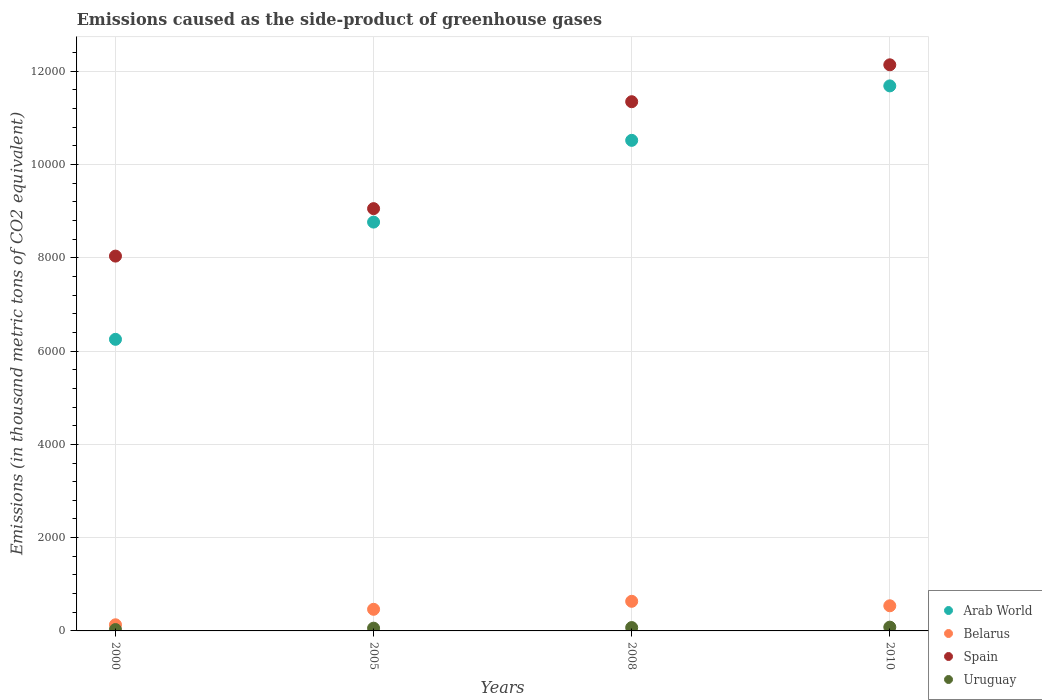What is the emissions caused as the side-product of greenhouse gases in Spain in 2000?
Provide a succinct answer. 8037.1. Across all years, what is the maximum emissions caused as the side-product of greenhouse gases in Belarus?
Give a very brief answer. 635.2. Across all years, what is the minimum emissions caused as the side-product of greenhouse gases in Belarus?
Your response must be concise. 131.6. In which year was the emissions caused as the side-product of greenhouse gases in Arab World maximum?
Make the answer very short. 2010. What is the total emissions caused as the side-product of greenhouse gases in Belarus in the graph?
Offer a terse response. 1769.4. What is the difference between the emissions caused as the side-product of greenhouse gases in Spain in 2000 and that in 2005?
Offer a very short reply. -1018. What is the difference between the emissions caused as the side-product of greenhouse gases in Belarus in 2008 and the emissions caused as the side-product of greenhouse gases in Arab World in 2010?
Your answer should be compact. -1.11e+04. What is the average emissions caused as the side-product of greenhouse gases in Spain per year?
Make the answer very short. 1.01e+04. In the year 2010, what is the difference between the emissions caused as the side-product of greenhouse gases in Arab World and emissions caused as the side-product of greenhouse gases in Spain?
Keep it short and to the point. -452. What is the ratio of the emissions caused as the side-product of greenhouse gases in Spain in 2005 to that in 2008?
Offer a very short reply. 0.8. Is the emissions caused as the side-product of greenhouse gases in Uruguay in 2000 less than that in 2010?
Your answer should be compact. Yes. Is the difference between the emissions caused as the side-product of greenhouse gases in Arab World in 2000 and 2010 greater than the difference between the emissions caused as the side-product of greenhouse gases in Spain in 2000 and 2010?
Give a very brief answer. No. What is the difference between the highest and the second highest emissions caused as the side-product of greenhouse gases in Belarus?
Keep it short and to the point. 96.2. What is the difference between the highest and the lowest emissions caused as the side-product of greenhouse gases in Spain?
Provide a short and direct response. 4101.9. Is it the case that in every year, the sum of the emissions caused as the side-product of greenhouse gases in Belarus and emissions caused as the side-product of greenhouse gases in Arab World  is greater than the sum of emissions caused as the side-product of greenhouse gases in Uruguay and emissions caused as the side-product of greenhouse gases in Spain?
Offer a terse response. No. Is the emissions caused as the side-product of greenhouse gases in Uruguay strictly less than the emissions caused as the side-product of greenhouse gases in Belarus over the years?
Offer a terse response. Yes. How many dotlines are there?
Your answer should be very brief. 4. How many years are there in the graph?
Your answer should be very brief. 4. What is the difference between two consecutive major ticks on the Y-axis?
Give a very brief answer. 2000. Are the values on the major ticks of Y-axis written in scientific E-notation?
Give a very brief answer. No. Does the graph contain any zero values?
Provide a succinct answer. No. Does the graph contain grids?
Keep it short and to the point. Yes. Where does the legend appear in the graph?
Keep it short and to the point. Bottom right. How many legend labels are there?
Offer a terse response. 4. What is the title of the graph?
Make the answer very short. Emissions caused as the side-product of greenhouse gases. Does "Middle East & North Africa (developing only)" appear as one of the legend labels in the graph?
Ensure brevity in your answer.  No. What is the label or title of the X-axis?
Offer a terse response. Years. What is the label or title of the Y-axis?
Keep it short and to the point. Emissions (in thousand metric tons of CO2 equivalent). What is the Emissions (in thousand metric tons of CO2 equivalent) in Arab World in 2000?
Ensure brevity in your answer.  6252.6. What is the Emissions (in thousand metric tons of CO2 equivalent) of Belarus in 2000?
Provide a succinct answer. 131.6. What is the Emissions (in thousand metric tons of CO2 equivalent) of Spain in 2000?
Ensure brevity in your answer.  8037.1. What is the Emissions (in thousand metric tons of CO2 equivalent) of Uruguay in 2000?
Offer a terse response. 29.3. What is the Emissions (in thousand metric tons of CO2 equivalent) in Arab World in 2005?
Give a very brief answer. 8766.4. What is the Emissions (in thousand metric tons of CO2 equivalent) in Belarus in 2005?
Ensure brevity in your answer.  463.6. What is the Emissions (in thousand metric tons of CO2 equivalent) of Spain in 2005?
Provide a short and direct response. 9055.1. What is the Emissions (in thousand metric tons of CO2 equivalent) of Uruguay in 2005?
Provide a succinct answer. 58.7. What is the Emissions (in thousand metric tons of CO2 equivalent) of Arab World in 2008?
Keep it short and to the point. 1.05e+04. What is the Emissions (in thousand metric tons of CO2 equivalent) in Belarus in 2008?
Your answer should be compact. 635.2. What is the Emissions (in thousand metric tons of CO2 equivalent) of Spain in 2008?
Provide a short and direct response. 1.13e+04. What is the Emissions (in thousand metric tons of CO2 equivalent) of Uruguay in 2008?
Provide a succinct answer. 71.8. What is the Emissions (in thousand metric tons of CO2 equivalent) of Arab World in 2010?
Offer a terse response. 1.17e+04. What is the Emissions (in thousand metric tons of CO2 equivalent) of Belarus in 2010?
Make the answer very short. 539. What is the Emissions (in thousand metric tons of CO2 equivalent) in Spain in 2010?
Ensure brevity in your answer.  1.21e+04. What is the Emissions (in thousand metric tons of CO2 equivalent) of Uruguay in 2010?
Ensure brevity in your answer.  81. Across all years, what is the maximum Emissions (in thousand metric tons of CO2 equivalent) in Arab World?
Your answer should be very brief. 1.17e+04. Across all years, what is the maximum Emissions (in thousand metric tons of CO2 equivalent) in Belarus?
Provide a short and direct response. 635.2. Across all years, what is the maximum Emissions (in thousand metric tons of CO2 equivalent) in Spain?
Offer a terse response. 1.21e+04. Across all years, what is the minimum Emissions (in thousand metric tons of CO2 equivalent) of Arab World?
Make the answer very short. 6252.6. Across all years, what is the minimum Emissions (in thousand metric tons of CO2 equivalent) of Belarus?
Your answer should be compact. 131.6. Across all years, what is the minimum Emissions (in thousand metric tons of CO2 equivalent) of Spain?
Offer a very short reply. 8037.1. Across all years, what is the minimum Emissions (in thousand metric tons of CO2 equivalent) of Uruguay?
Your answer should be very brief. 29.3. What is the total Emissions (in thousand metric tons of CO2 equivalent) of Arab World in the graph?
Give a very brief answer. 3.72e+04. What is the total Emissions (in thousand metric tons of CO2 equivalent) in Belarus in the graph?
Offer a very short reply. 1769.4. What is the total Emissions (in thousand metric tons of CO2 equivalent) in Spain in the graph?
Keep it short and to the point. 4.06e+04. What is the total Emissions (in thousand metric tons of CO2 equivalent) of Uruguay in the graph?
Your answer should be very brief. 240.8. What is the difference between the Emissions (in thousand metric tons of CO2 equivalent) in Arab World in 2000 and that in 2005?
Keep it short and to the point. -2513.8. What is the difference between the Emissions (in thousand metric tons of CO2 equivalent) of Belarus in 2000 and that in 2005?
Provide a short and direct response. -332. What is the difference between the Emissions (in thousand metric tons of CO2 equivalent) in Spain in 2000 and that in 2005?
Offer a very short reply. -1018. What is the difference between the Emissions (in thousand metric tons of CO2 equivalent) of Uruguay in 2000 and that in 2005?
Keep it short and to the point. -29.4. What is the difference between the Emissions (in thousand metric tons of CO2 equivalent) of Arab World in 2000 and that in 2008?
Keep it short and to the point. -4266.6. What is the difference between the Emissions (in thousand metric tons of CO2 equivalent) in Belarus in 2000 and that in 2008?
Provide a succinct answer. -503.6. What is the difference between the Emissions (in thousand metric tons of CO2 equivalent) of Spain in 2000 and that in 2008?
Give a very brief answer. -3310.7. What is the difference between the Emissions (in thousand metric tons of CO2 equivalent) of Uruguay in 2000 and that in 2008?
Your answer should be very brief. -42.5. What is the difference between the Emissions (in thousand metric tons of CO2 equivalent) in Arab World in 2000 and that in 2010?
Provide a short and direct response. -5434.4. What is the difference between the Emissions (in thousand metric tons of CO2 equivalent) of Belarus in 2000 and that in 2010?
Your response must be concise. -407.4. What is the difference between the Emissions (in thousand metric tons of CO2 equivalent) in Spain in 2000 and that in 2010?
Provide a succinct answer. -4101.9. What is the difference between the Emissions (in thousand metric tons of CO2 equivalent) in Uruguay in 2000 and that in 2010?
Your answer should be very brief. -51.7. What is the difference between the Emissions (in thousand metric tons of CO2 equivalent) in Arab World in 2005 and that in 2008?
Make the answer very short. -1752.8. What is the difference between the Emissions (in thousand metric tons of CO2 equivalent) of Belarus in 2005 and that in 2008?
Ensure brevity in your answer.  -171.6. What is the difference between the Emissions (in thousand metric tons of CO2 equivalent) in Spain in 2005 and that in 2008?
Offer a terse response. -2292.7. What is the difference between the Emissions (in thousand metric tons of CO2 equivalent) of Uruguay in 2005 and that in 2008?
Offer a very short reply. -13.1. What is the difference between the Emissions (in thousand metric tons of CO2 equivalent) of Arab World in 2005 and that in 2010?
Provide a short and direct response. -2920.6. What is the difference between the Emissions (in thousand metric tons of CO2 equivalent) of Belarus in 2005 and that in 2010?
Provide a succinct answer. -75.4. What is the difference between the Emissions (in thousand metric tons of CO2 equivalent) of Spain in 2005 and that in 2010?
Your response must be concise. -3083.9. What is the difference between the Emissions (in thousand metric tons of CO2 equivalent) in Uruguay in 2005 and that in 2010?
Your response must be concise. -22.3. What is the difference between the Emissions (in thousand metric tons of CO2 equivalent) of Arab World in 2008 and that in 2010?
Provide a succinct answer. -1167.8. What is the difference between the Emissions (in thousand metric tons of CO2 equivalent) in Belarus in 2008 and that in 2010?
Your answer should be compact. 96.2. What is the difference between the Emissions (in thousand metric tons of CO2 equivalent) in Spain in 2008 and that in 2010?
Give a very brief answer. -791.2. What is the difference between the Emissions (in thousand metric tons of CO2 equivalent) of Uruguay in 2008 and that in 2010?
Keep it short and to the point. -9.2. What is the difference between the Emissions (in thousand metric tons of CO2 equivalent) of Arab World in 2000 and the Emissions (in thousand metric tons of CO2 equivalent) of Belarus in 2005?
Your answer should be very brief. 5789. What is the difference between the Emissions (in thousand metric tons of CO2 equivalent) of Arab World in 2000 and the Emissions (in thousand metric tons of CO2 equivalent) of Spain in 2005?
Provide a succinct answer. -2802.5. What is the difference between the Emissions (in thousand metric tons of CO2 equivalent) in Arab World in 2000 and the Emissions (in thousand metric tons of CO2 equivalent) in Uruguay in 2005?
Keep it short and to the point. 6193.9. What is the difference between the Emissions (in thousand metric tons of CO2 equivalent) of Belarus in 2000 and the Emissions (in thousand metric tons of CO2 equivalent) of Spain in 2005?
Give a very brief answer. -8923.5. What is the difference between the Emissions (in thousand metric tons of CO2 equivalent) of Belarus in 2000 and the Emissions (in thousand metric tons of CO2 equivalent) of Uruguay in 2005?
Your answer should be very brief. 72.9. What is the difference between the Emissions (in thousand metric tons of CO2 equivalent) in Spain in 2000 and the Emissions (in thousand metric tons of CO2 equivalent) in Uruguay in 2005?
Keep it short and to the point. 7978.4. What is the difference between the Emissions (in thousand metric tons of CO2 equivalent) in Arab World in 2000 and the Emissions (in thousand metric tons of CO2 equivalent) in Belarus in 2008?
Your response must be concise. 5617.4. What is the difference between the Emissions (in thousand metric tons of CO2 equivalent) in Arab World in 2000 and the Emissions (in thousand metric tons of CO2 equivalent) in Spain in 2008?
Make the answer very short. -5095.2. What is the difference between the Emissions (in thousand metric tons of CO2 equivalent) in Arab World in 2000 and the Emissions (in thousand metric tons of CO2 equivalent) in Uruguay in 2008?
Keep it short and to the point. 6180.8. What is the difference between the Emissions (in thousand metric tons of CO2 equivalent) of Belarus in 2000 and the Emissions (in thousand metric tons of CO2 equivalent) of Spain in 2008?
Make the answer very short. -1.12e+04. What is the difference between the Emissions (in thousand metric tons of CO2 equivalent) of Belarus in 2000 and the Emissions (in thousand metric tons of CO2 equivalent) of Uruguay in 2008?
Offer a terse response. 59.8. What is the difference between the Emissions (in thousand metric tons of CO2 equivalent) in Spain in 2000 and the Emissions (in thousand metric tons of CO2 equivalent) in Uruguay in 2008?
Your answer should be compact. 7965.3. What is the difference between the Emissions (in thousand metric tons of CO2 equivalent) of Arab World in 2000 and the Emissions (in thousand metric tons of CO2 equivalent) of Belarus in 2010?
Provide a succinct answer. 5713.6. What is the difference between the Emissions (in thousand metric tons of CO2 equivalent) of Arab World in 2000 and the Emissions (in thousand metric tons of CO2 equivalent) of Spain in 2010?
Keep it short and to the point. -5886.4. What is the difference between the Emissions (in thousand metric tons of CO2 equivalent) of Arab World in 2000 and the Emissions (in thousand metric tons of CO2 equivalent) of Uruguay in 2010?
Your answer should be compact. 6171.6. What is the difference between the Emissions (in thousand metric tons of CO2 equivalent) in Belarus in 2000 and the Emissions (in thousand metric tons of CO2 equivalent) in Spain in 2010?
Keep it short and to the point. -1.20e+04. What is the difference between the Emissions (in thousand metric tons of CO2 equivalent) in Belarus in 2000 and the Emissions (in thousand metric tons of CO2 equivalent) in Uruguay in 2010?
Your response must be concise. 50.6. What is the difference between the Emissions (in thousand metric tons of CO2 equivalent) in Spain in 2000 and the Emissions (in thousand metric tons of CO2 equivalent) in Uruguay in 2010?
Make the answer very short. 7956.1. What is the difference between the Emissions (in thousand metric tons of CO2 equivalent) of Arab World in 2005 and the Emissions (in thousand metric tons of CO2 equivalent) of Belarus in 2008?
Your response must be concise. 8131.2. What is the difference between the Emissions (in thousand metric tons of CO2 equivalent) in Arab World in 2005 and the Emissions (in thousand metric tons of CO2 equivalent) in Spain in 2008?
Give a very brief answer. -2581.4. What is the difference between the Emissions (in thousand metric tons of CO2 equivalent) in Arab World in 2005 and the Emissions (in thousand metric tons of CO2 equivalent) in Uruguay in 2008?
Your response must be concise. 8694.6. What is the difference between the Emissions (in thousand metric tons of CO2 equivalent) of Belarus in 2005 and the Emissions (in thousand metric tons of CO2 equivalent) of Spain in 2008?
Ensure brevity in your answer.  -1.09e+04. What is the difference between the Emissions (in thousand metric tons of CO2 equivalent) of Belarus in 2005 and the Emissions (in thousand metric tons of CO2 equivalent) of Uruguay in 2008?
Provide a succinct answer. 391.8. What is the difference between the Emissions (in thousand metric tons of CO2 equivalent) of Spain in 2005 and the Emissions (in thousand metric tons of CO2 equivalent) of Uruguay in 2008?
Offer a very short reply. 8983.3. What is the difference between the Emissions (in thousand metric tons of CO2 equivalent) of Arab World in 2005 and the Emissions (in thousand metric tons of CO2 equivalent) of Belarus in 2010?
Offer a terse response. 8227.4. What is the difference between the Emissions (in thousand metric tons of CO2 equivalent) in Arab World in 2005 and the Emissions (in thousand metric tons of CO2 equivalent) in Spain in 2010?
Keep it short and to the point. -3372.6. What is the difference between the Emissions (in thousand metric tons of CO2 equivalent) in Arab World in 2005 and the Emissions (in thousand metric tons of CO2 equivalent) in Uruguay in 2010?
Give a very brief answer. 8685.4. What is the difference between the Emissions (in thousand metric tons of CO2 equivalent) in Belarus in 2005 and the Emissions (in thousand metric tons of CO2 equivalent) in Spain in 2010?
Make the answer very short. -1.17e+04. What is the difference between the Emissions (in thousand metric tons of CO2 equivalent) in Belarus in 2005 and the Emissions (in thousand metric tons of CO2 equivalent) in Uruguay in 2010?
Your response must be concise. 382.6. What is the difference between the Emissions (in thousand metric tons of CO2 equivalent) of Spain in 2005 and the Emissions (in thousand metric tons of CO2 equivalent) of Uruguay in 2010?
Provide a succinct answer. 8974.1. What is the difference between the Emissions (in thousand metric tons of CO2 equivalent) of Arab World in 2008 and the Emissions (in thousand metric tons of CO2 equivalent) of Belarus in 2010?
Your response must be concise. 9980.2. What is the difference between the Emissions (in thousand metric tons of CO2 equivalent) of Arab World in 2008 and the Emissions (in thousand metric tons of CO2 equivalent) of Spain in 2010?
Offer a very short reply. -1619.8. What is the difference between the Emissions (in thousand metric tons of CO2 equivalent) of Arab World in 2008 and the Emissions (in thousand metric tons of CO2 equivalent) of Uruguay in 2010?
Provide a short and direct response. 1.04e+04. What is the difference between the Emissions (in thousand metric tons of CO2 equivalent) of Belarus in 2008 and the Emissions (in thousand metric tons of CO2 equivalent) of Spain in 2010?
Your answer should be very brief. -1.15e+04. What is the difference between the Emissions (in thousand metric tons of CO2 equivalent) in Belarus in 2008 and the Emissions (in thousand metric tons of CO2 equivalent) in Uruguay in 2010?
Offer a terse response. 554.2. What is the difference between the Emissions (in thousand metric tons of CO2 equivalent) of Spain in 2008 and the Emissions (in thousand metric tons of CO2 equivalent) of Uruguay in 2010?
Your response must be concise. 1.13e+04. What is the average Emissions (in thousand metric tons of CO2 equivalent) of Arab World per year?
Ensure brevity in your answer.  9306.3. What is the average Emissions (in thousand metric tons of CO2 equivalent) in Belarus per year?
Your answer should be compact. 442.35. What is the average Emissions (in thousand metric tons of CO2 equivalent) in Spain per year?
Make the answer very short. 1.01e+04. What is the average Emissions (in thousand metric tons of CO2 equivalent) in Uruguay per year?
Make the answer very short. 60.2. In the year 2000, what is the difference between the Emissions (in thousand metric tons of CO2 equivalent) in Arab World and Emissions (in thousand metric tons of CO2 equivalent) in Belarus?
Provide a short and direct response. 6121. In the year 2000, what is the difference between the Emissions (in thousand metric tons of CO2 equivalent) in Arab World and Emissions (in thousand metric tons of CO2 equivalent) in Spain?
Your answer should be very brief. -1784.5. In the year 2000, what is the difference between the Emissions (in thousand metric tons of CO2 equivalent) of Arab World and Emissions (in thousand metric tons of CO2 equivalent) of Uruguay?
Give a very brief answer. 6223.3. In the year 2000, what is the difference between the Emissions (in thousand metric tons of CO2 equivalent) in Belarus and Emissions (in thousand metric tons of CO2 equivalent) in Spain?
Make the answer very short. -7905.5. In the year 2000, what is the difference between the Emissions (in thousand metric tons of CO2 equivalent) of Belarus and Emissions (in thousand metric tons of CO2 equivalent) of Uruguay?
Provide a short and direct response. 102.3. In the year 2000, what is the difference between the Emissions (in thousand metric tons of CO2 equivalent) of Spain and Emissions (in thousand metric tons of CO2 equivalent) of Uruguay?
Provide a succinct answer. 8007.8. In the year 2005, what is the difference between the Emissions (in thousand metric tons of CO2 equivalent) of Arab World and Emissions (in thousand metric tons of CO2 equivalent) of Belarus?
Offer a very short reply. 8302.8. In the year 2005, what is the difference between the Emissions (in thousand metric tons of CO2 equivalent) in Arab World and Emissions (in thousand metric tons of CO2 equivalent) in Spain?
Provide a short and direct response. -288.7. In the year 2005, what is the difference between the Emissions (in thousand metric tons of CO2 equivalent) in Arab World and Emissions (in thousand metric tons of CO2 equivalent) in Uruguay?
Make the answer very short. 8707.7. In the year 2005, what is the difference between the Emissions (in thousand metric tons of CO2 equivalent) of Belarus and Emissions (in thousand metric tons of CO2 equivalent) of Spain?
Ensure brevity in your answer.  -8591.5. In the year 2005, what is the difference between the Emissions (in thousand metric tons of CO2 equivalent) in Belarus and Emissions (in thousand metric tons of CO2 equivalent) in Uruguay?
Offer a terse response. 404.9. In the year 2005, what is the difference between the Emissions (in thousand metric tons of CO2 equivalent) of Spain and Emissions (in thousand metric tons of CO2 equivalent) of Uruguay?
Offer a very short reply. 8996.4. In the year 2008, what is the difference between the Emissions (in thousand metric tons of CO2 equivalent) of Arab World and Emissions (in thousand metric tons of CO2 equivalent) of Belarus?
Offer a very short reply. 9884. In the year 2008, what is the difference between the Emissions (in thousand metric tons of CO2 equivalent) in Arab World and Emissions (in thousand metric tons of CO2 equivalent) in Spain?
Your answer should be compact. -828.6. In the year 2008, what is the difference between the Emissions (in thousand metric tons of CO2 equivalent) of Arab World and Emissions (in thousand metric tons of CO2 equivalent) of Uruguay?
Offer a terse response. 1.04e+04. In the year 2008, what is the difference between the Emissions (in thousand metric tons of CO2 equivalent) of Belarus and Emissions (in thousand metric tons of CO2 equivalent) of Spain?
Offer a very short reply. -1.07e+04. In the year 2008, what is the difference between the Emissions (in thousand metric tons of CO2 equivalent) of Belarus and Emissions (in thousand metric tons of CO2 equivalent) of Uruguay?
Your answer should be very brief. 563.4. In the year 2008, what is the difference between the Emissions (in thousand metric tons of CO2 equivalent) of Spain and Emissions (in thousand metric tons of CO2 equivalent) of Uruguay?
Your response must be concise. 1.13e+04. In the year 2010, what is the difference between the Emissions (in thousand metric tons of CO2 equivalent) in Arab World and Emissions (in thousand metric tons of CO2 equivalent) in Belarus?
Your response must be concise. 1.11e+04. In the year 2010, what is the difference between the Emissions (in thousand metric tons of CO2 equivalent) of Arab World and Emissions (in thousand metric tons of CO2 equivalent) of Spain?
Ensure brevity in your answer.  -452. In the year 2010, what is the difference between the Emissions (in thousand metric tons of CO2 equivalent) of Arab World and Emissions (in thousand metric tons of CO2 equivalent) of Uruguay?
Provide a short and direct response. 1.16e+04. In the year 2010, what is the difference between the Emissions (in thousand metric tons of CO2 equivalent) of Belarus and Emissions (in thousand metric tons of CO2 equivalent) of Spain?
Provide a short and direct response. -1.16e+04. In the year 2010, what is the difference between the Emissions (in thousand metric tons of CO2 equivalent) in Belarus and Emissions (in thousand metric tons of CO2 equivalent) in Uruguay?
Ensure brevity in your answer.  458. In the year 2010, what is the difference between the Emissions (in thousand metric tons of CO2 equivalent) of Spain and Emissions (in thousand metric tons of CO2 equivalent) of Uruguay?
Offer a terse response. 1.21e+04. What is the ratio of the Emissions (in thousand metric tons of CO2 equivalent) of Arab World in 2000 to that in 2005?
Your answer should be very brief. 0.71. What is the ratio of the Emissions (in thousand metric tons of CO2 equivalent) in Belarus in 2000 to that in 2005?
Your response must be concise. 0.28. What is the ratio of the Emissions (in thousand metric tons of CO2 equivalent) in Spain in 2000 to that in 2005?
Keep it short and to the point. 0.89. What is the ratio of the Emissions (in thousand metric tons of CO2 equivalent) in Uruguay in 2000 to that in 2005?
Your answer should be compact. 0.5. What is the ratio of the Emissions (in thousand metric tons of CO2 equivalent) in Arab World in 2000 to that in 2008?
Your answer should be compact. 0.59. What is the ratio of the Emissions (in thousand metric tons of CO2 equivalent) in Belarus in 2000 to that in 2008?
Give a very brief answer. 0.21. What is the ratio of the Emissions (in thousand metric tons of CO2 equivalent) in Spain in 2000 to that in 2008?
Offer a very short reply. 0.71. What is the ratio of the Emissions (in thousand metric tons of CO2 equivalent) in Uruguay in 2000 to that in 2008?
Your response must be concise. 0.41. What is the ratio of the Emissions (in thousand metric tons of CO2 equivalent) in Arab World in 2000 to that in 2010?
Provide a succinct answer. 0.54. What is the ratio of the Emissions (in thousand metric tons of CO2 equivalent) of Belarus in 2000 to that in 2010?
Provide a succinct answer. 0.24. What is the ratio of the Emissions (in thousand metric tons of CO2 equivalent) in Spain in 2000 to that in 2010?
Your answer should be very brief. 0.66. What is the ratio of the Emissions (in thousand metric tons of CO2 equivalent) in Uruguay in 2000 to that in 2010?
Your response must be concise. 0.36. What is the ratio of the Emissions (in thousand metric tons of CO2 equivalent) of Arab World in 2005 to that in 2008?
Your answer should be very brief. 0.83. What is the ratio of the Emissions (in thousand metric tons of CO2 equivalent) of Belarus in 2005 to that in 2008?
Provide a succinct answer. 0.73. What is the ratio of the Emissions (in thousand metric tons of CO2 equivalent) in Spain in 2005 to that in 2008?
Offer a very short reply. 0.8. What is the ratio of the Emissions (in thousand metric tons of CO2 equivalent) in Uruguay in 2005 to that in 2008?
Keep it short and to the point. 0.82. What is the ratio of the Emissions (in thousand metric tons of CO2 equivalent) in Arab World in 2005 to that in 2010?
Keep it short and to the point. 0.75. What is the ratio of the Emissions (in thousand metric tons of CO2 equivalent) of Belarus in 2005 to that in 2010?
Provide a short and direct response. 0.86. What is the ratio of the Emissions (in thousand metric tons of CO2 equivalent) of Spain in 2005 to that in 2010?
Provide a short and direct response. 0.75. What is the ratio of the Emissions (in thousand metric tons of CO2 equivalent) of Uruguay in 2005 to that in 2010?
Make the answer very short. 0.72. What is the ratio of the Emissions (in thousand metric tons of CO2 equivalent) of Arab World in 2008 to that in 2010?
Your answer should be compact. 0.9. What is the ratio of the Emissions (in thousand metric tons of CO2 equivalent) in Belarus in 2008 to that in 2010?
Make the answer very short. 1.18. What is the ratio of the Emissions (in thousand metric tons of CO2 equivalent) in Spain in 2008 to that in 2010?
Ensure brevity in your answer.  0.93. What is the ratio of the Emissions (in thousand metric tons of CO2 equivalent) in Uruguay in 2008 to that in 2010?
Your answer should be very brief. 0.89. What is the difference between the highest and the second highest Emissions (in thousand metric tons of CO2 equivalent) in Arab World?
Your answer should be compact. 1167.8. What is the difference between the highest and the second highest Emissions (in thousand metric tons of CO2 equivalent) in Belarus?
Offer a very short reply. 96.2. What is the difference between the highest and the second highest Emissions (in thousand metric tons of CO2 equivalent) in Spain?
Provide a succinct answer. 791.2. What is the difference between the highest and the second highest Emissions (in thousand metric tons of CO2 equivalent) in Uruguay?
Provide a short and direct response. 9.2. What is the difference between the highest and the lowest Emissions (in thousand metric tons of CO2 equivalent) of Arab World?
Your response must be concise. 5434.4. What is the difference between the highest and the lowest Emissions (in thousand metric tons of CO2 equivalent) in Belarus?
Keep it short and to the point. 503.6. What is the difference between the highest and the lowest Emissions (in thousand metric tons of CO2 equivalent) of Spain?
Keep it short and to the point. 4101.9. What is the difference between the highest and the lowest Emissions (in thousand metric tons of CO2 equivalent) of Uruguay?
Your answer should be very brief. 51.7. 